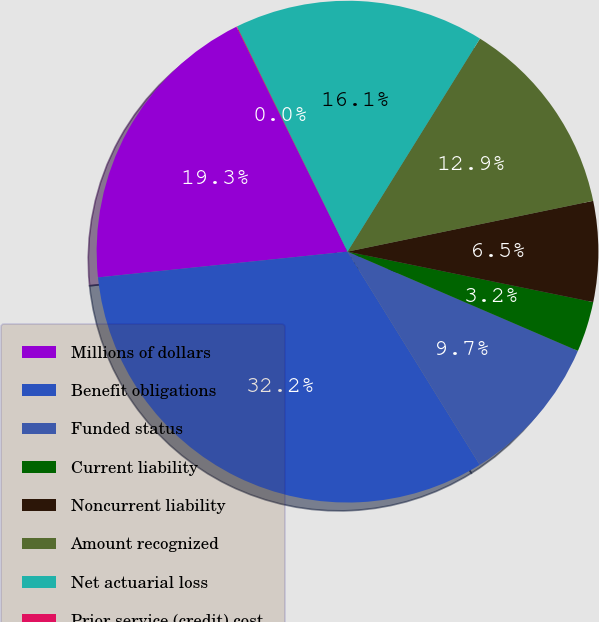Convert chart. <chart><loc_0><loc_0><loc_500><loc_500><pie_chart><fcel>Millions of dollars<fcel>Benefit obligations<fcel>Funded status<fcel>Current liability<fcel>Noncurrent liability<fcel>Amount recognized<fcel>Net actuarial loss<fcel>Prior service (credit) cost<nl><fcel>19.33%<fcel>32.2%<fcel>9.69%<fcel>3.25%<fcel>6.47%<fcel>12.9%<fcel>16.12%<fcel>0.04%<nl></chart> 